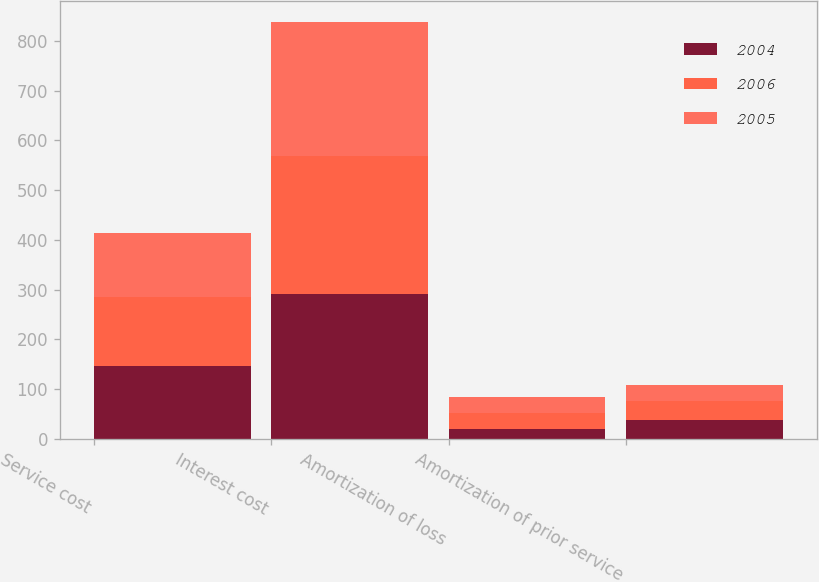Convert chart to OTSL. <chart><loc_0><loc_0><loc_500><loc_500><stacked_bar_chart><ecel><fcel>Service cost<fcel>Interest cost<fcel>Amortization of loss<fcel>Amortization of prior service<nl><fcel>2004<fcel>147<fcel>291<fcel>19<fcel>37<nl><fcel>2006<fcel>138<fcel>277<fcel>33<fcel>38<nl><fcel>2005<fcel>128<fcel>270<fcel>32<fcel>34<nl></chart> 